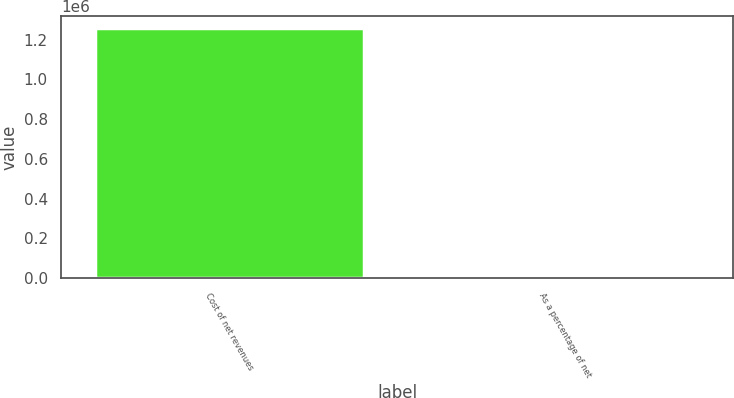Convert chart to OTSL. <chart><loc_0><loc_0><loc_500><loc_500><bar_chart><fcel>Cost of net revenues<fcel>As a percentage of net<nl><fcel>1.25679e+06<fcel>21.1<nl></chart> 